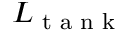Convert formula to latex. <formula><loc_0><loc_0><loc_500><loc_500>L _ { t a n k }</formula> 